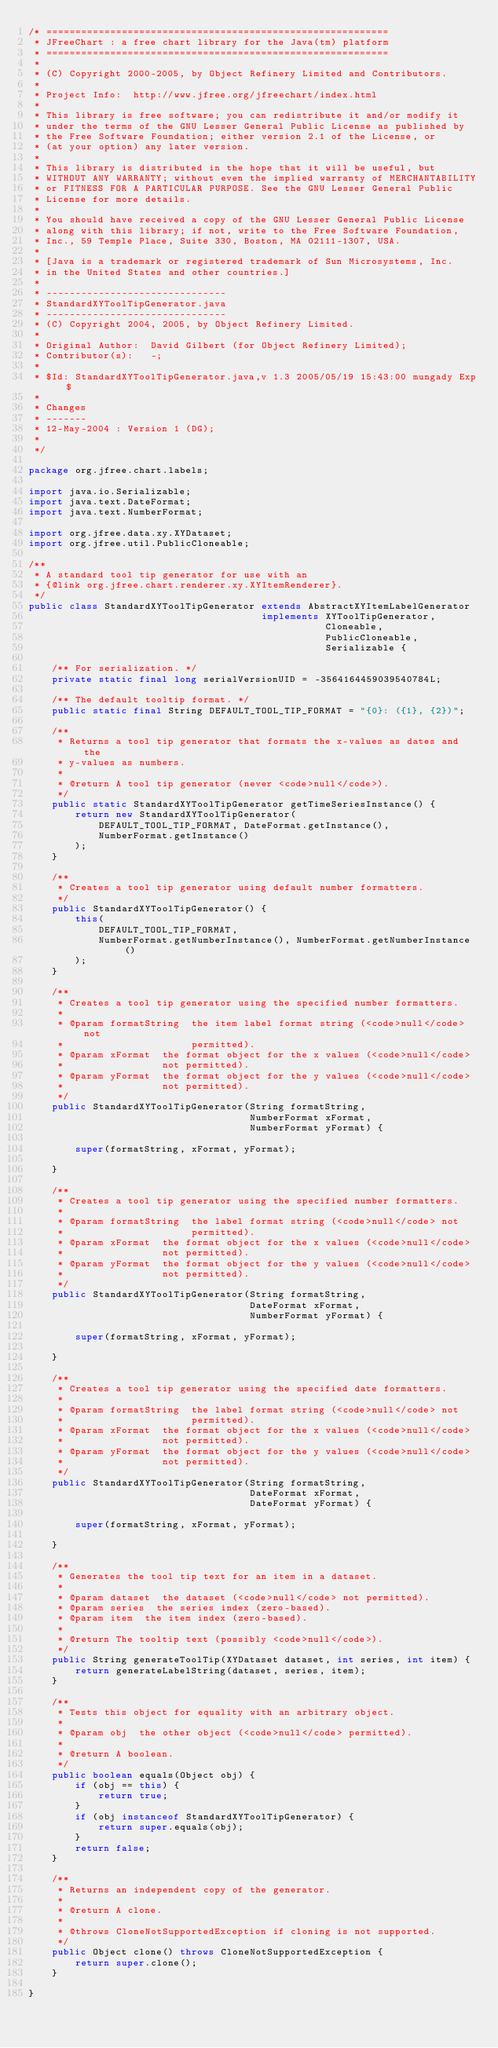Convert code to text. <code><loc_0><loc_0><loc_500><loc_500><_Java_>/* ===========================================================
 * JFreeChart : a free chart library for the Java(tm) platform
 * ===========================================================
 *
 * (C) Copyright 2000-2005, by Object Refinery Limited and Contributors.
 *
 * Project Info:  http://www.jfree.org/jfreechart/index.html
 *
 * This library is free software; you can redistribute it and/or modify it 
 * under the terms of the GNU Lesser General Public License as published by 
 * the Free Software Foundation; either version 2.1 of the License, or 
 * (at your option) any later version.
 *
 * This library is distributed in the hope that it will be useful, but 
 * WITHOUT ANY WARRANTY; without even the implied warranty of MERCHANTABILITY 
 * or FITNESS FOR A PARTICULAR PURPOSE. See the GNU Lesser General Public 
 * License for more details.
 *
 * You should have received a copy of the GNU Lesser General Public License 
 * along with this library; if not, write to the Free Software Foundation, 
 * Inc., 59 Temple Place, Suite 330, Boston, MA 02111-1307, USA.
 *
 * [Java is a trademark or registered trademark of Sun Microsystems, Inc. 
 * in the United States and other countries.]
 *
 * -------------------------------
 * StandardXYToolTipGenerator.java
 * -------------------------------
 * (C) Copyright 2004, 2005, by Object Refinery Limited.
 *
 * Original Author:  David Gilbert (for Object Refinery Limited);
 * Contributor(s):   -;
 *
 * $Id: StandardXYToolTipGenerator.java,v 1.3 2005/05/19 15:43:00 mungady Exp $
 *
 * Changes
 * -------
 * 12-May-2004 : Version 1 (DG);
 *
 */

package org.jfree.chart.labels;

import java.io.Serializable;
import java.text.DateFormat;
import java.text.NumberFormat;

import org.jfree.data.xy.XYDataset;
import org.jfree.util.PublicCloneable;

/**
 * A standard tool tip generator for use with an 
 * {@link org.jfree.chart.renderer.xy.XYItemRenderer}.
 */
public class StandardXYToolTipGenerator extends AbstractXYItemLabelGenerator  
                                        implements XYToolTipGenerator,
                                                   Cloneable, 
                                                   PublicCloneable,
                                                   Serializable {

    /** For serialization. */
    private static final long serialVersionUID = -3564164459039540784L;    
    
    /** The default tooltip format. */
    public static final String DEFAULT_TOOL_TIP_FORMAT = "{0}: ({1}, {2})";

    /**
     * Returns a tool tip generator that formats the x-values as dates and the 
     * y-values as numbers.
     * 
     * @return A tool tip generator (never <code>null</code>).
     */
    public static StandardXYToolTipGenerator getTimeSeriesInstance() {
        return new StandardXYToolTipGenerator(
            DEFAULT_TOOL_TIP_FORMAT, DateFormat.getInstance(), 
            NumberFormat.getInstance()
        );
    }
    
    /**
     * Creates a tool tip generator using default number formatters.
     */
    public StandardXYToolTipGenerator() {
        this(
            DEFAULT_TOOL_TIP_FORMAT,
            NumberFormat.getNumberInstance(), NumberFormat.getNumberInstance()
        );
    }

    /**
     * Creates a tool tip generator using the specified number formatters.
     *
     * @param formatString  the item label format string (<code>null</code> not
     *                      permitted).
     * @param xFormat  the format object for the x values (<code>null</code> 
     *                 not permitted).
     * @param yFormat  the format object for the y values (<code>null</code> 
     *                 not permitted).
     */
    public StandardXYToolTipGenerator(String formatString,
                                      NumberFormat xFormat, 
                                      NumberFormat yFormat) {
        
        super(formatString, xFormat, yFormat);
    
    }

    /**
     * Creates a tool tip generator using the specified number formatters.
     *
     * @param formatString  the label format string (<code>null</code> not 
     *                      permitted).
     * @param xFormat  the format object for the x values (<code>null</code> 
     *                 not permitted).
     * @param yFormat  the format object for the y values (<code>null</code> 
     *                 not permitted).
     */
    public StandardXYToolTipGenerator(String formatString,
                                      DateFormat xFormat, 
                                      NumberFormat yFormat) {
        
        super(formatString, xFormat, yFormat);
    
    }

    /**
     * Creates a tool tip generator using the specified date formatters.
     *
     * @param formatString  the label format string (<code>null</code> not 
     *                      permitted).
     * @param xFormat  the format object for the x values (<code>null</code> 
     *                 not permitted).
     * @param yFormat  the format object for the y values (<code>null</code> 
     *                 not permitted).
     */
    public StandardXYToolTipGenerator(String formatString,
                                      DateFormat xFormat, 
                                      DateFormat yFormat) {
        
        super(formatString, xFormat, yFormat);
    
    }

    /**
     * Generates the tool tip text for an item in a dataset.
     *
     * @param dataset  the dataset (<code>null</code> not permitted).
     * @param series  the series index (zero-based).
     * @param item  the item index (zero-based).
     *
     * @return The tooltip text (possibly <code>null</code>).
     */
    public String generateToolTip(XYDataset dataset, int series, int item) {
        return generateLabelString(dataset, series, item);
    }

    /**
     * Tests this object for equality with an arbitrary object.
     *
     * @param obj  the other object (<code>null</code> permitted).
     *
     * @return A boolean.
     */
    public boolean equals(Object obj) {
        if (obj == this) {
            return true;
        }
        if (obj instanceof StandardXYToolTipGenerator) {
            return super.equals(obj);
        }
        return false;
    }

    /**
     * Returns an independent copy of the generator.
     * 
     * @return A clone.
     * 
     * @throws CloneNotSupportedException if cloning is not supported.
     */
    public Object clone() throws CloneNotSupportedException { 
        return super.clone();
    }
    
}
</code> 